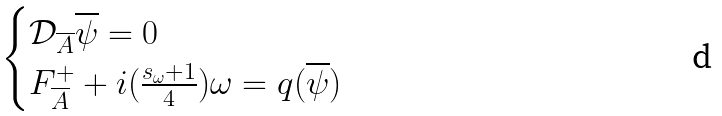Convert formula to latex. <formula><loc_0><loc_0><loc_500><loc_500>\begin{cases} \mathcal { D } _ { \overline { A } } \overline { \psi } = 0 \\ F ^ { + } _ { \overline { A } } + i ( \frac { s _ { \omega } + 1 } { 4 } ) \omega = q ( \overline { \psi } ) \end{cases}</formula> 